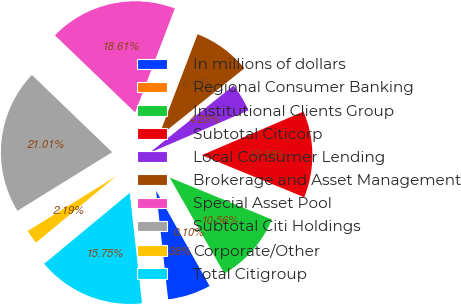Convert chart. <chart><loc_0><loc_0><loc_500><loc_500><pie_chart><fcel>In millions of dollars<fcel>Regional Consumer Banking<fcel>Institutional Clients Group<fcel>Subtotal Citicorp<fcel>Local Consumer Lending<fcel>Brokerage and Asset Management<fcel>Special Asset Pool<fcel>Subtotal Citi Holdings<fcel>Corporate/Other<fcel>Total Citigroup<nl><fcel>6.38%<fcel>0.1%<fcel>10.56%<fcel>12.65%<fcel>4.28%<fcel>8.47%<fcel>18.61%<fcel>21.01%<fcel>2.19%<fcel>15.75%<nl></chart> 